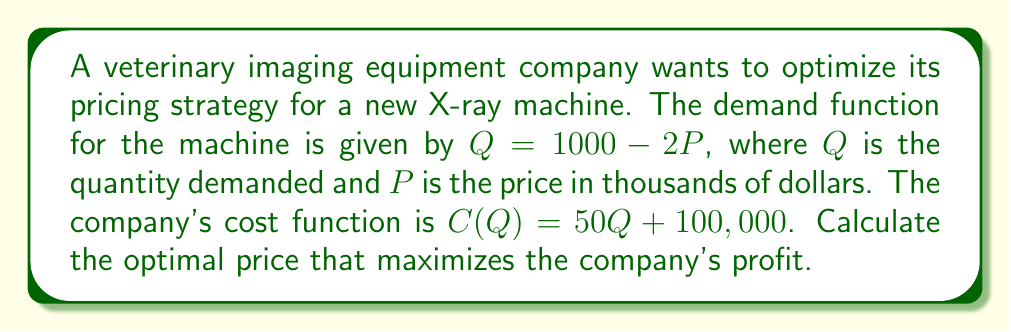Can you solve this math problem? To find the optimal price, we need to follow these steps:

1. Express the profit function in terms of P:
   Revenue = $P \cdot Q = P(1000 - 2P)$
   Cost = $C(Q) = 50(1000 - 2P) + 100,000 = 50,000 - 100P + 100,000$
   Profit = $\pi(P) = P(1000 - 2P) - (50,000 - 100P + 100,000)$
   $\pi(P) = 1000P - 2P^2 - 150,000 + 100P = -2P^2 + 1100P - 150,000$

2. Find the derivative of the profit function:
   $\frac{d\pi}{dP} = -4P + 1100$

3. Set the derivative equal to zero and solve for P:
   $-4P + 1100 = 0$
   $-4P = -1100$
   $P = 275$

4. Verify that this is a maximum by checking the second derivative:
   $\frac{d^2\pi}{dP^2} = -4$, which is negative, confirming a maximum.

5. Calculate the optimal quantity:
   $Q = 1000 - 2P = 1000 - 2(275) = 450$

Therefore, the optimal price is $275,000 per X-ray machine.
Answer: $275,000 